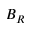<formula> <loc_0><loc_0><loc_500><loc_500>B _ { R }</formula> 